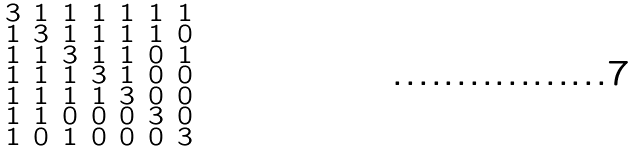Convert formula to latex. <formula><loc_0><loc_0><loc_500><loc_500>\begin{smallmatrix} 3 & 1 & 1 & 1 & 1 & 1 & 1 \\ 1 & 3 & 1 & 1 & 1 & 1 & 0 \\ 1 & 1 & 3 & 1 & 1 & 0 & 1 \\ 1 & 1 & 1 & 3 & 1 & 0 & 0 \\ 1 & 1 & 1 & 1 & 3 & 0 & 0 \\ 1 & 1 & 0 & 0 & 0 & 3 & 0 \\ 1 & 0 & 1 & 0 & 0 & 0 & 3 \end{smallmatrix}</formula> 